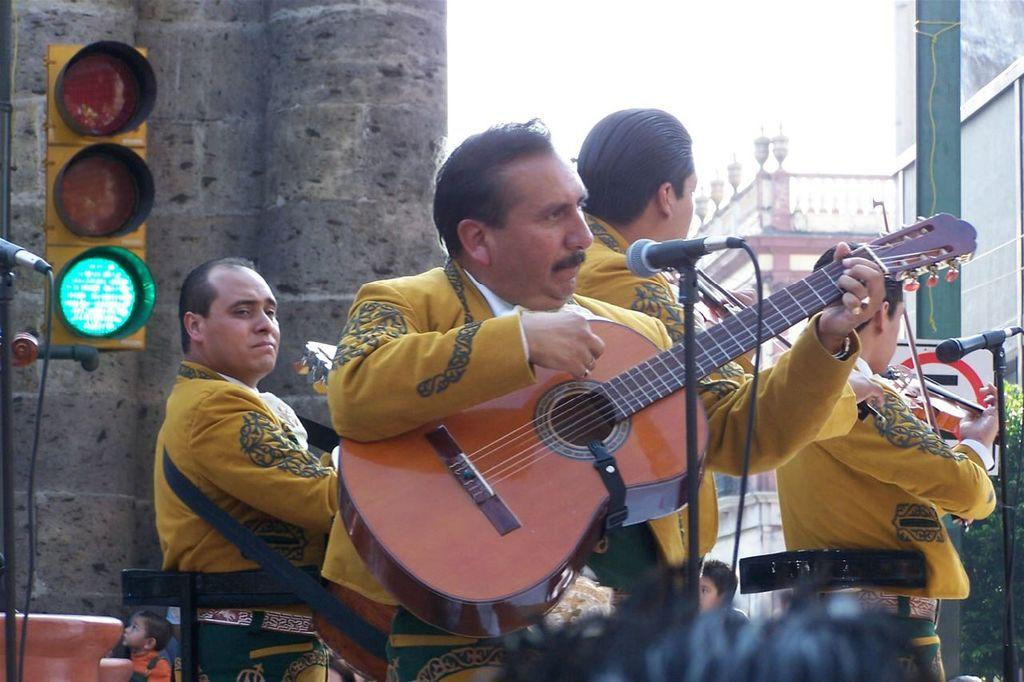What are the people in the image doing? The people in the image are playing musical instruments. Where are the musical instruments located in the image? The musical instruments are in the middle of the image. What is visible behind the people playing musical instruments? There is a traffic signal behind the people playing musical instruments. What is located behind the traffic signal in the image? There is a wall behind the traffic signal. What type of waves can be seen crashing on the shore in the image? There are no waves or shore visible in the image; it features people playing musical instruments with a traffic signal and a wall in the background. 